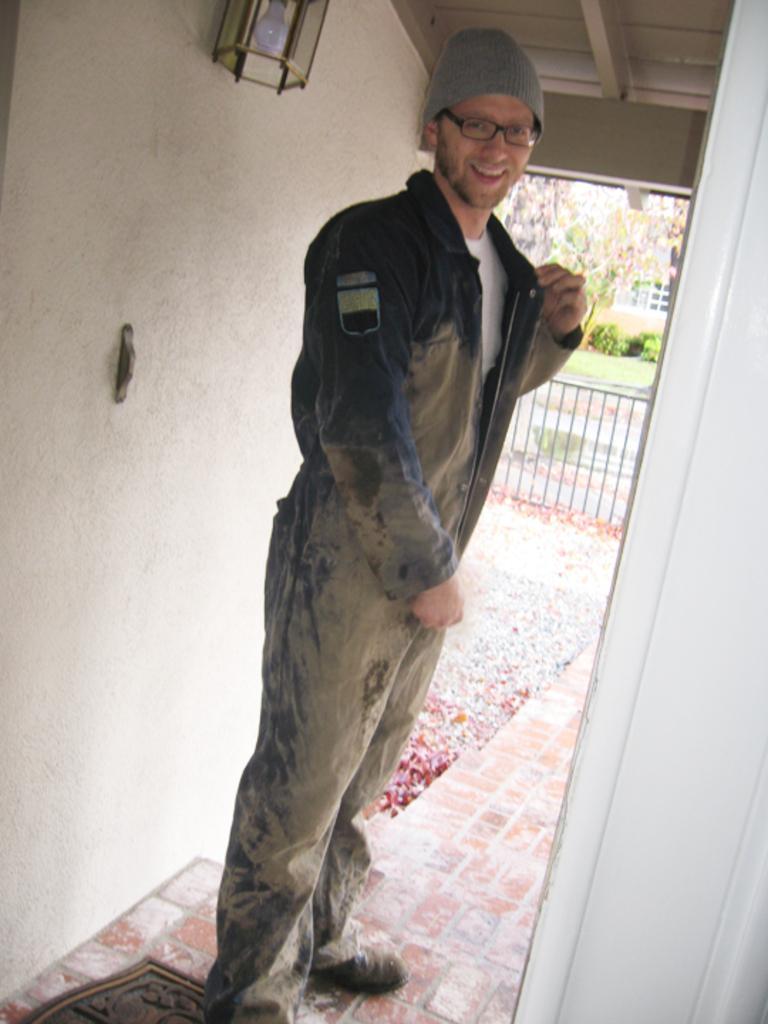Please provide a concise description of this image. In this image there is a person wearing goggles and a cap, there is a light attached to the wall, a fence, a tree, few garden plants, grass and a building. 